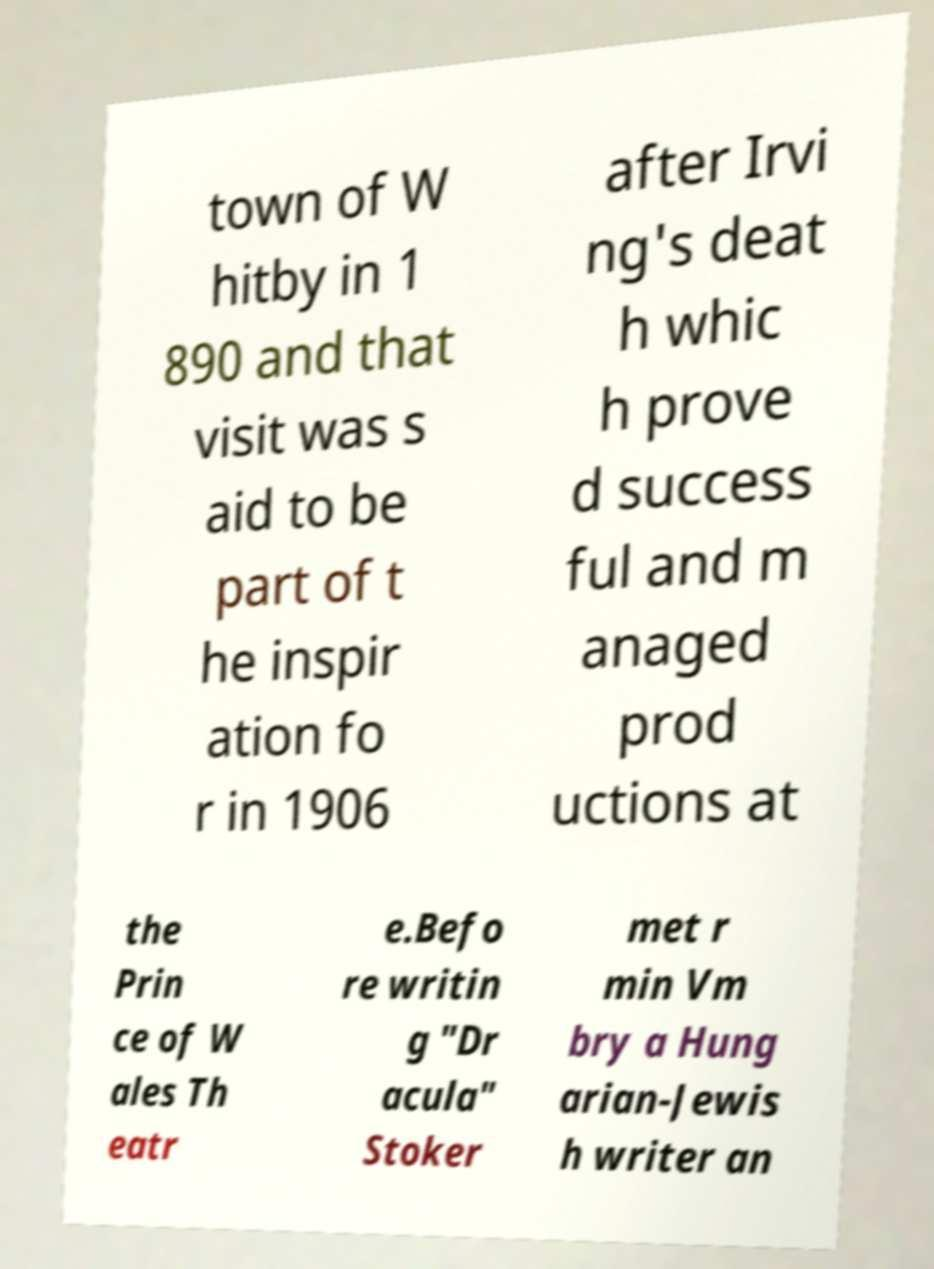Could you extract and type out the text from this image? town of W hitby in 1 890 and that visit was s aid to be part of t he inspir ation fo r in 1906 after Irvi ng's deat h whic h prove d success ful and m anaged prod uctions at the Prin ce of W ales Th eatr e.Befo re writin g "Dr acula" Stoker met r min Vm bry a Hung arian-Jewis h writer an 